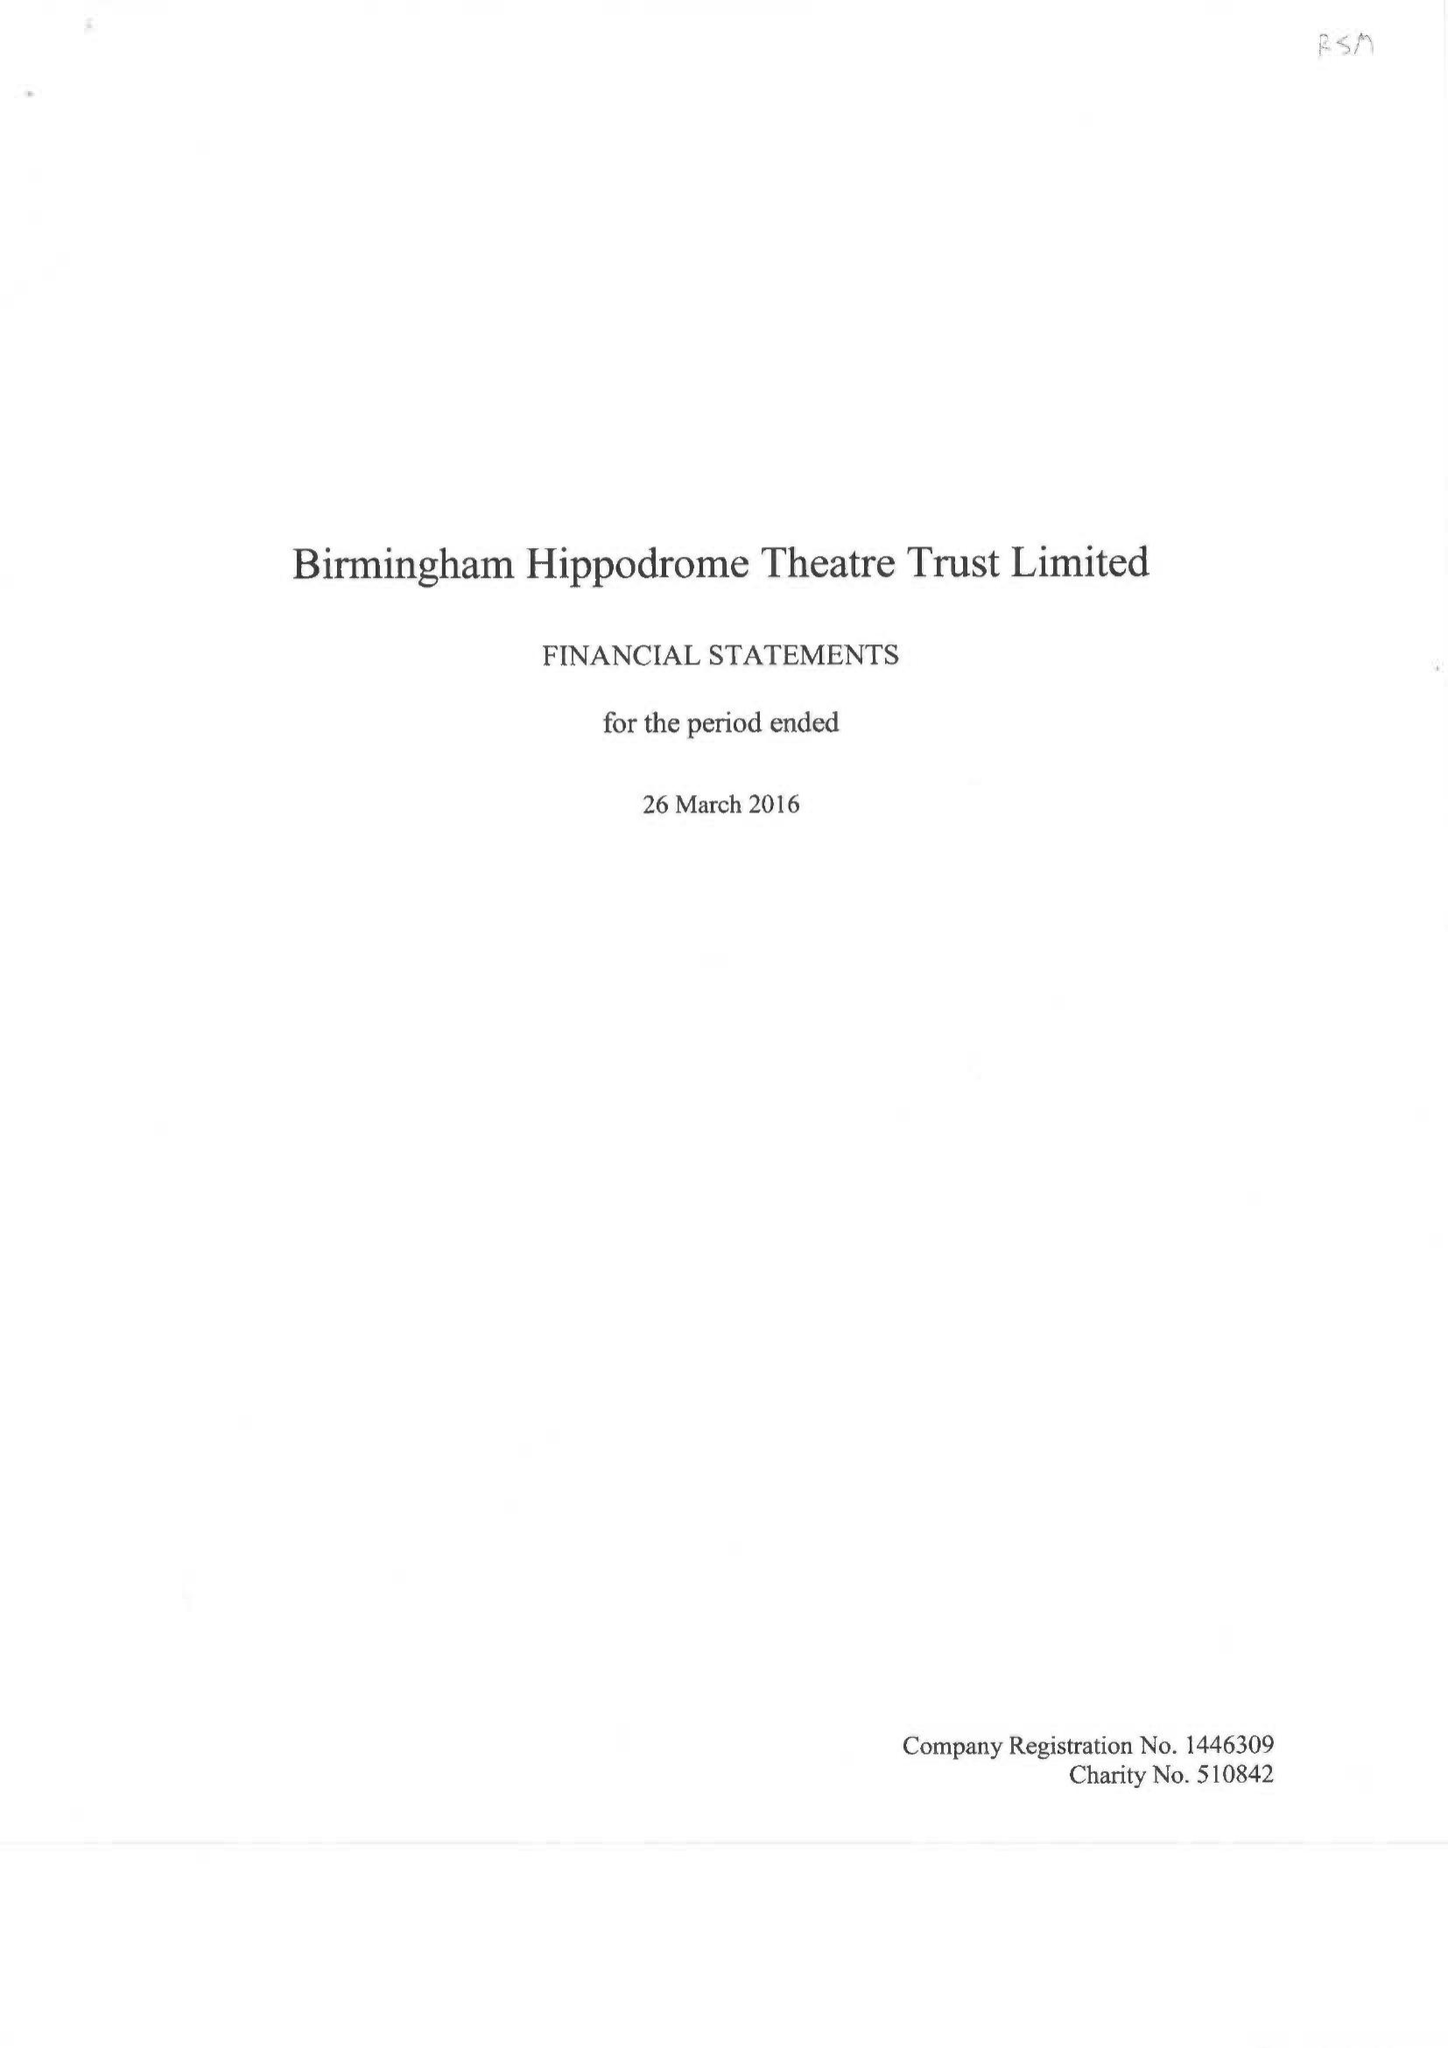What is the value for the address__postcode?
Answer the question using a single word or phrase. B5 4TB 